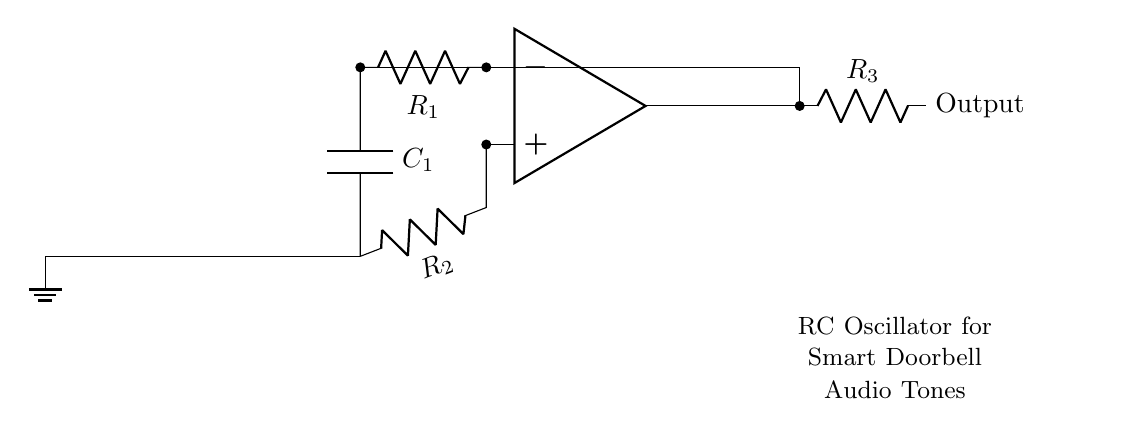What is the function of the operational amplifier in this circuit? The operational amplifier acts as a comparator in this RC oscillator circuit, providing gain to amplify the voltage differences, which helps create oscillations.
Answer: Comparator What type of components are R1, R2, and R3? R1, R2, and R3 are resistors that set the charging and discharging times of the capacitor, affecting the frequency of the oscillation.
Answer: Resistors How many energy storage elements are present in this circuit? There is one energy storage element present, which is the capacitor C1, responsible for storing energy and allowing oscillation creation in this RC oscillator.
Answer: One What does R3 connect to in this circuit? R3 connects to the output of the oscillator, allowing it to deliver audio tone signals to the output without feedback into the circuit.
Answer: Output What is the overall purpose of this RC oscillator in a smart doorbell system? The RC oscillator generates audio tones that can be used for notification or alert purposes when someone presses the doorbell button, indicating property viewings.
Answer: Audio tones What would happen if the capacitor value C1 was increased? Increasing C1 would result in a lower frequency of the oscillation, making the tone generated by the doorbell sound lower in pitch due to the longer charge/discharge cycles.
Answer: Lower frequency How is feedback achieved in this RC oscillator circuit? Feedback is achieved by connecting the output back to the inverting input of the op-amp, allowing the circuit to alternate between high and low states, creating oscillations.
Answer: Feedback connection 